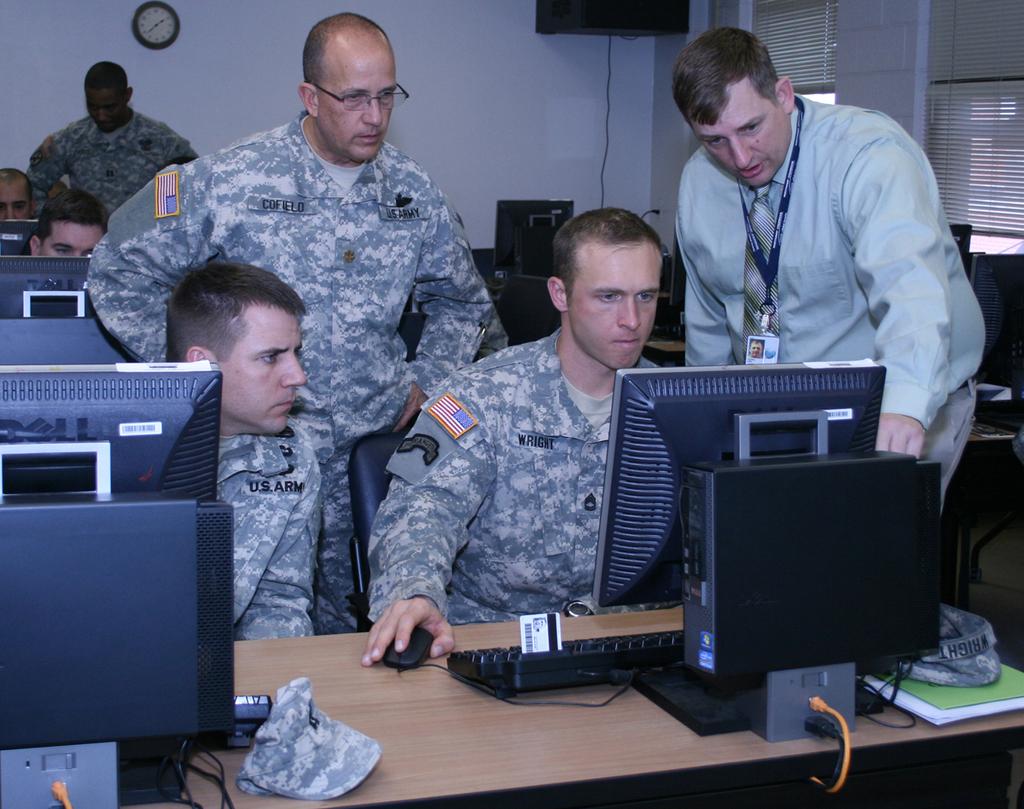What service are they in?
Provide a succinct answer. Army. 